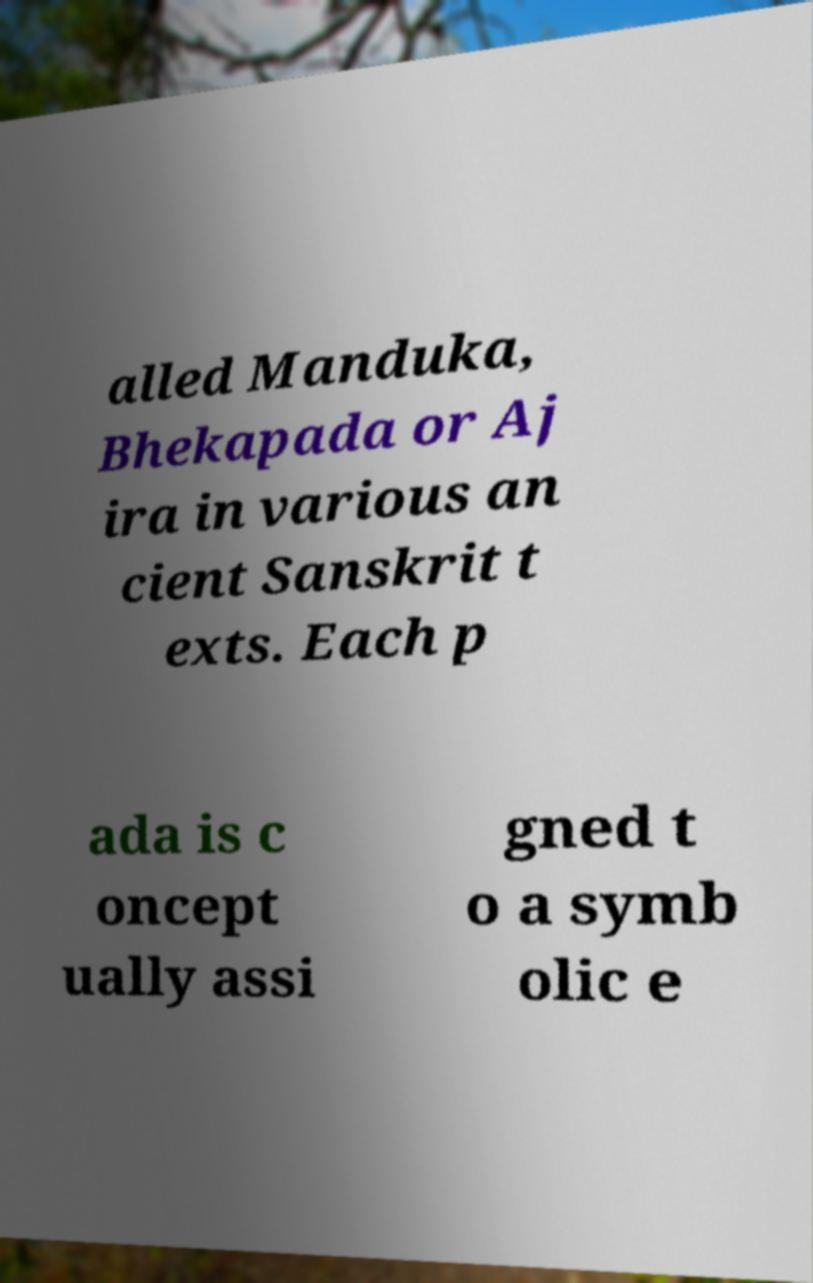Please identify and transcribe the text found in this image. alled Manduka, Bhekapada or Aj ira in various an cient Sanskrit t exts. Each p ada is c oncept ually assi gned t o a symb olic e 